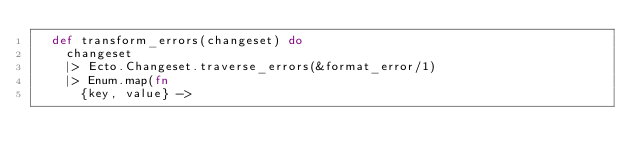Convert code to text. <code><loc_0><loc_0><loc_500><loc_500><_Elixir_>  def transform_errors(changeset) do
    changeset
    |> Ecto.Changeset.traverse_errors(&format_error/1)
    |> Enum.map(fn
      {key, value} -></code> 